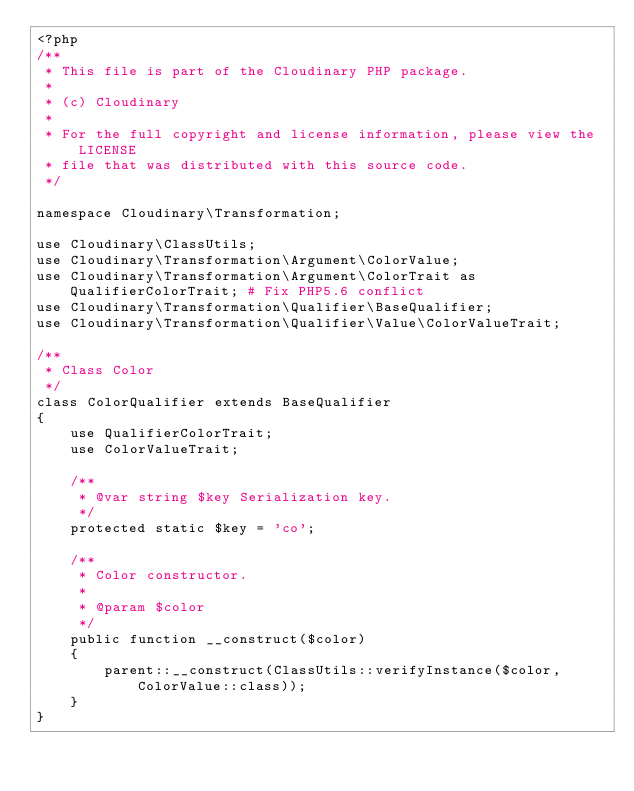<code> <loc_0><loc_0><loc_500><loc_500><_PHP_><?php
/**
 * This file is part of the Cloudinary PHP package.
 *
 * (c) Cloudinary
 *
 * For the full copyright and license information, please view the LICENSE
 * file that was distributed with this source code.
 */

namespace Cloudinary\Transformation;

use Cloudinary\ClassUtils;
use Cloudinary\Transformation\Argument\ColorValue;
use Cloudinary\Transformation\Argument\ColorTrait as QualifierColorTrait; # Fix PHP5.6 conflict
use Cloudinary\Transformation\Qualifier\BaseQualifier;
use Cloudinary\Transformation\Qualifier\Value\ColorValueTrait;

/**
 * Class Color
 */
class ColorQualifier extends BaseQualifier
{
    use QualifierColorTrait;
    use ColorValueTrait;

    /**
     * @var string $key Serialization key.
     */
    protected static $key = 'co';

    /**
     * Color constructor.
     *
     * @param $color
     */
    public function __construct($color)
    {
        parent::__construct(ClassUtils::verifyInstance($color, ColorValue::class));
    }
}
</code> 